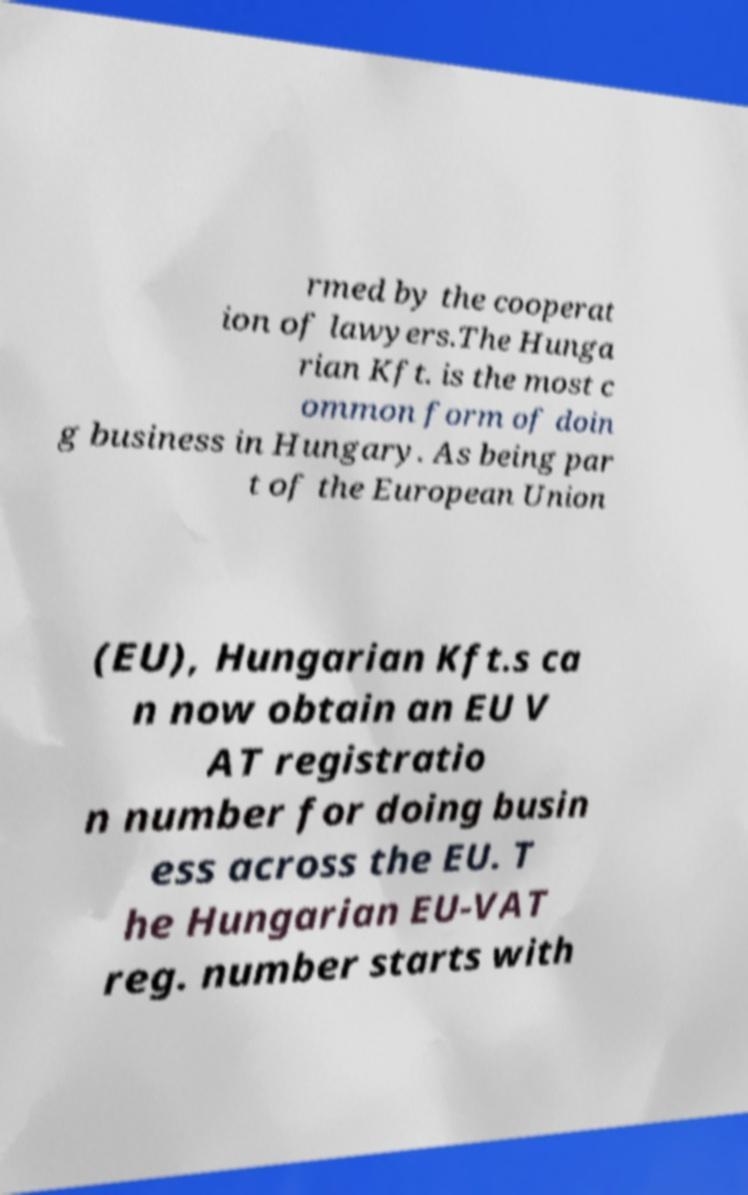Could you assist in decoding the text presented in this image and type it out clearly? rmed by the cooperat ion of lawyers.The Hunga rian Kft. is the most c ommon form of doin g business in Hungary. As being par t of the European Union (EU), Hungarian Kft.s ca n now obtain an EU V AT registratio n number for doing busin ess across the EU. T he Hungarian EU-VAT reg. number starts with 